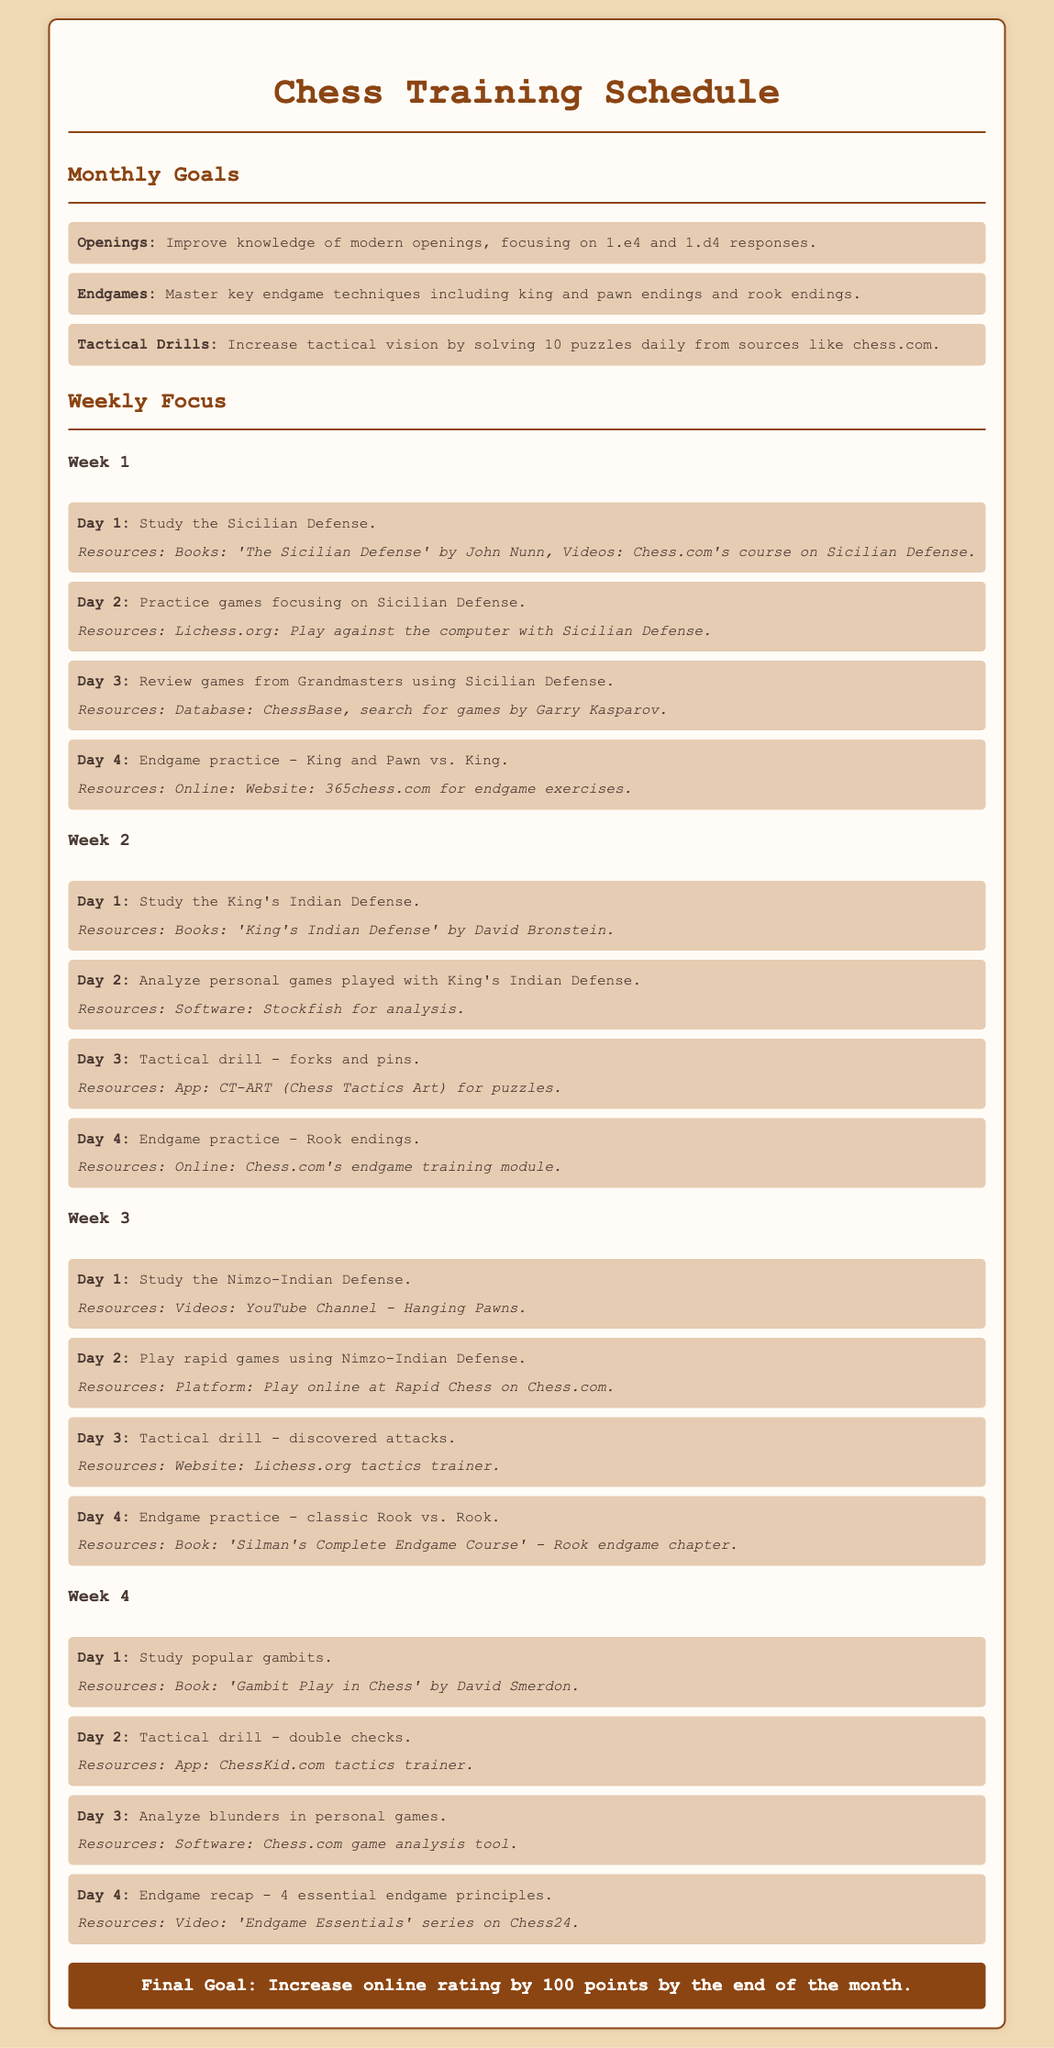What are the monthly goals? The monthly goals include improving knowledge of modern openings, mastering key endgame techniques, and increasing tactical vision.
Answer: Openings, Endgames, Tactical Drills What is the final goal of the training schedule? The final goal aims for an increase in the online rating by 100 points by the end of the month.
Answer: Increase online rating by 100 points Which opening is studied in Week 1? The opening studied in Week 1 is the Sicilian Defense.
Answer: Sicilian Defense How many puzzles should be solved daily in Tactical Drills? The document mentions solving 10 puzzles daily in Tactical Drills for improvement.
Answer: 10 puzzles What type of endgame is practiced on Day 4 of Week 1? The type of endgame practiced is King and Pawn vs. King.
Answer: King and Pawn vs. King Which resource is suggested for studying the King's Indian Defense? The suggested resource for studying the King's Indian Defense is a book by David Bronstein.
Answer: 'King's Indian Defense' by David Bronstein What tactical drill is focused on during Week 2? In Week 2, the focus is on forks and pins as the tactical drill.
Answer: Forks and pins Which tactical drill is practiced on Day 2 of Week 4? The tactical drill practiced on Day 2 of Week 4 is double checks.
Answer: Double checks 